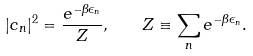<formula> <loc_0><loc_0><loc_500><loc_500>| c _ { n } | ^ { 2 } = \frac { e ^ { - \beta \epsilon _ { n } } } { Z } , \quad Z \equiv \sum _ { n } e ^ { - \beta \epsilon _ { n } } .</formula> 